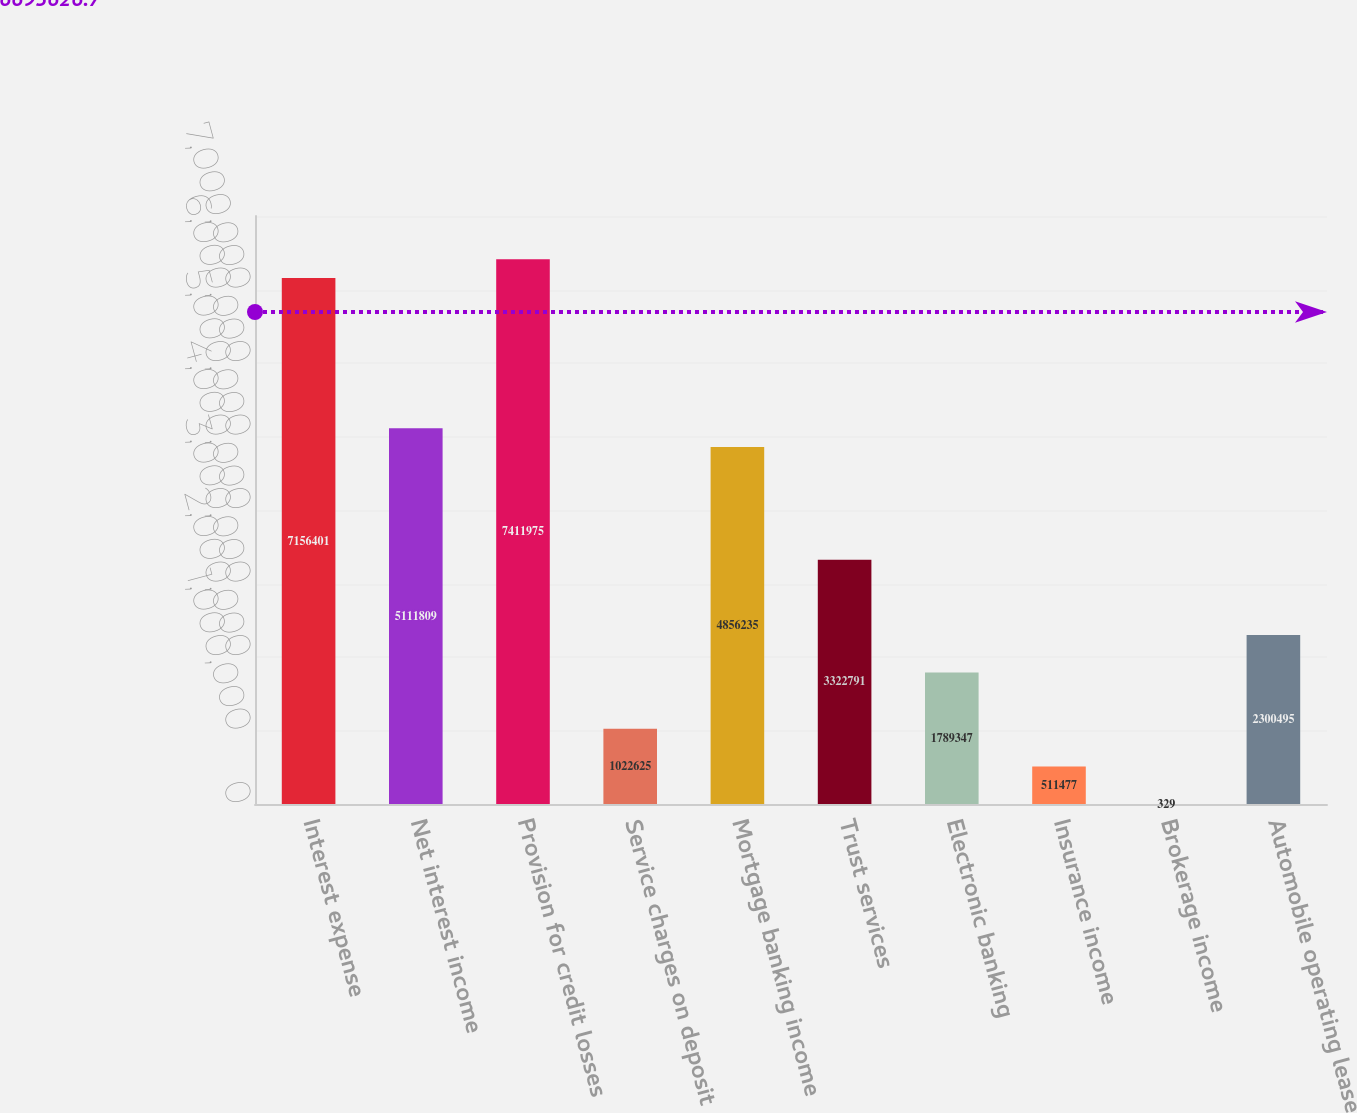Convert chart to OTSL. <chart><loc_0><loc_0><loc_500><loc_500><bar_chart><fcel>Interest expense<fcel>Net interest income<fcel>Provision for credit losses<fcel>Service charges on deposit<fcel>Mortgage banking income<fcel>Trust services<fcel>Electronic banking<fcel>Insurance income<fcel>Brokerage income<fcel>Automobile operating lease<nl><fcel>7.1564e+06<fcel>5.11181e+06<fcel>7.41198e+06<fcel>1.02262e+06<fcel>4.85624e+06<fcel>3.32279e+06<fcel>1.78935e+06<fcel>511477<fcel>329<fcel>2.3005e+06<nl></chart> 